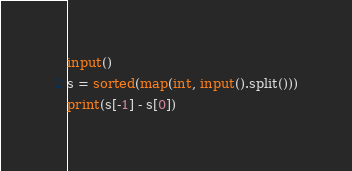Convert code to text. <code><loc_0><loc_0><loc_500><loc_500><_Python_>input()
s = sorted(map(int, input().split()))
print(s[-1] - s[0])</code> 